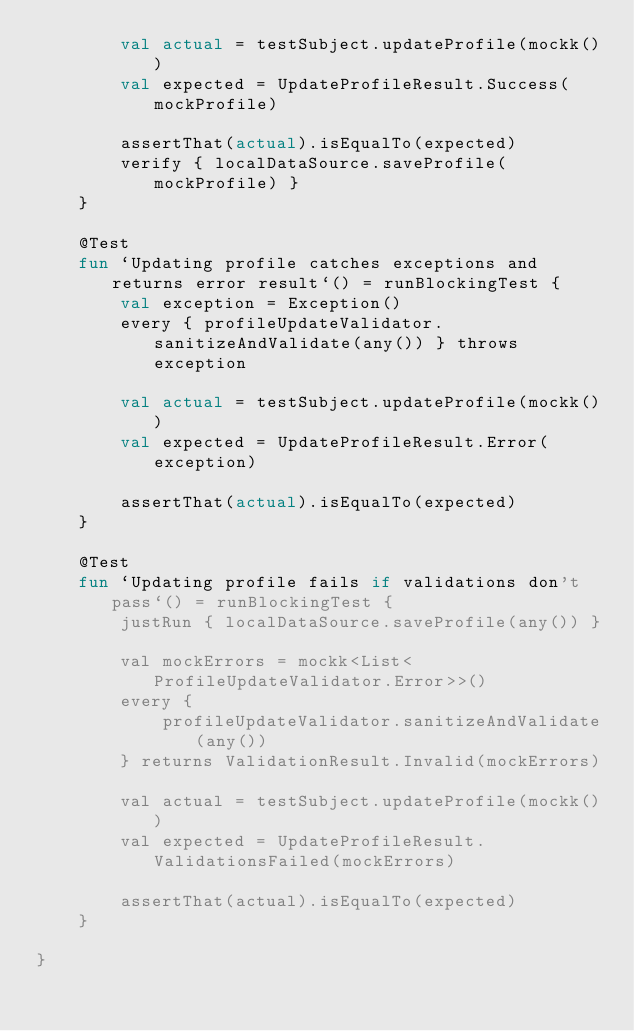<code> <loc_0><loc_0><loc_500><loc_500><_Kotlin_>        val actual = testSubject.updateProfile(mockk())
        val expected = UpdateProfileResult.Success(mockProfile)

        assertThat(actual).isEqualTo(expected)
        verify { localDataSource.saveProfile(mockProfile) }
    }

    @Test
    fun `Updating profile catches exceptions and returns error result`() = runBlockingTest {
        val exception = Exception()
        every { profileUpdateValidator.sanitizeAndValidate(any()) } throws exception

        val actual = testSubject.updateProfile(mockk())
        val expected = UpdateProfileResult.Error(exception)

        assertThat(actual).isEqualTo(expected)
    }

    @Test
    fun `Updating profile fails if validations don't pass`() = runBlockingTest {
        justRun { localDataSource.saveProfile(any()) }

        val mockErrors = mockk<List<ProfileUpdateValidator.Error>>()
        every {
            profileUpdateValidator.sanitizeAndValidate(any())
        } returns ValidationResult.Invalid(mockErrors)

        val actual = testSubject.updateProfile(mockk())
        val expected = UpdateProfileResult.ValidationsFailed(mockErrors)

        assertThat(actual).isEqualTo(expected)
    }

}
</code> 